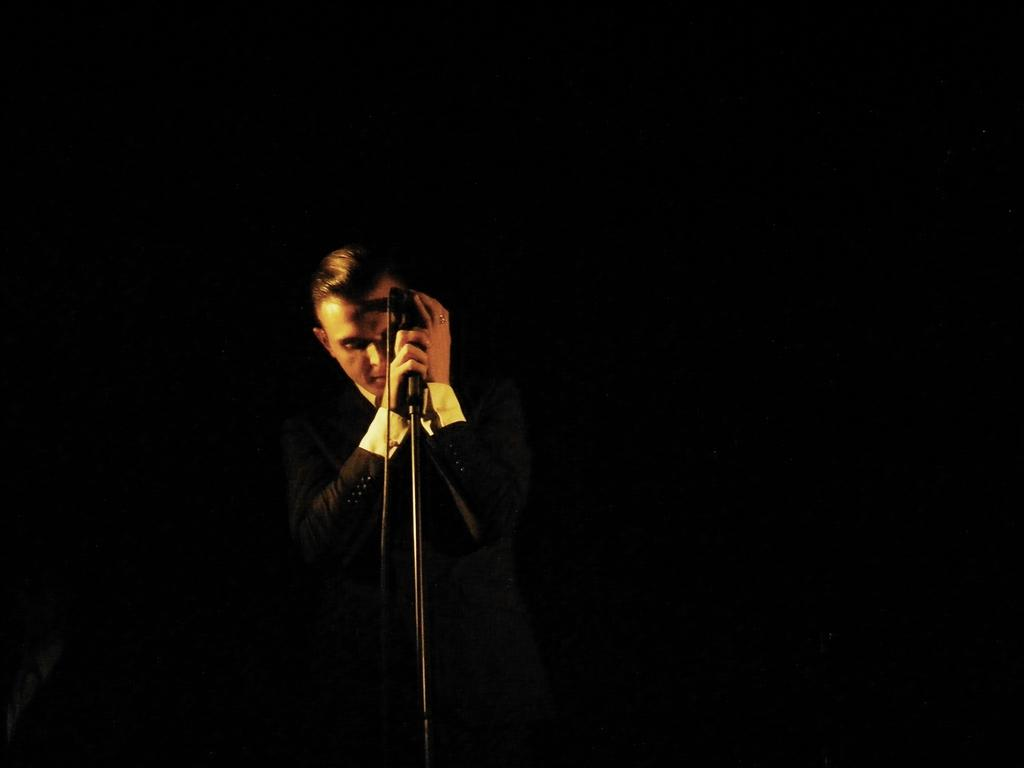Who is the main subject in the image? There is a man in the image. What is the man doing in the image? The man is standing in the image. What object is the man holding in the image? The man is holding a microphone in the image. What can be observed about the background of the image? The background of the image is dark. Can you see any wounds on the man in the image? There is no mention of any wounds on the man in the image, and therefore we cannot determine if any are present. Are there any rats visible in the image? There is no mention of any rats in the image, and therefore we cannot determine if any are present. 